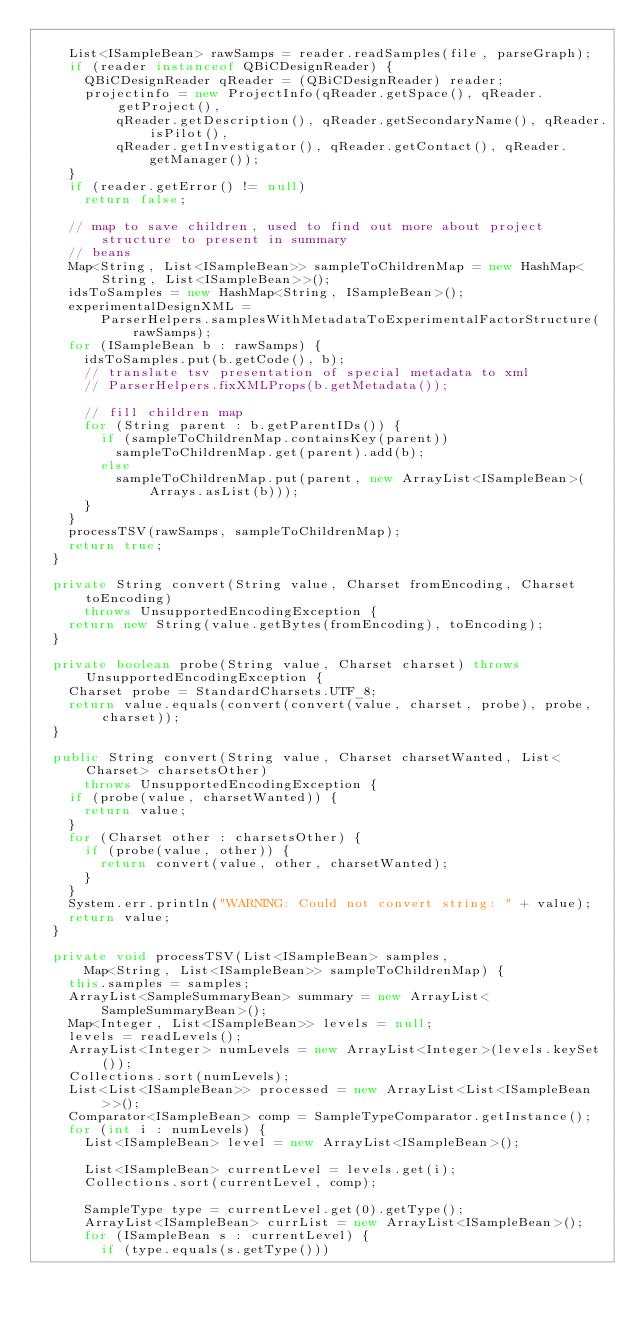Convert code to text. <code><loc_0><loc_0><loc_500><loc_500><_Java_>
    List<ISampleBean> rawSamps = reader.readSamples(file, parseGraph);
    if (reader instanceof QBiCDesignReader) {
      QBiCDesignReader qReader = (QBiCDesignReader) reader;
      projectinfo = new ProjectInfo(qReader.getSpace(), qReader.getProject(),
          qReader.getDescription(), qReader.getSecondaryName(), qReader.isPilot(),
          qReader.getInvestigator(), qReader.getContact(), qReader.getManager());
    }
    if (reader.getError() != null)
      return false;

    // map to save children, used to find out more about project structure to present in summary
    // beans
    Map<String, List<ISampleBean>> sampleToChildrenMap = new HashMap<String, List<ISampleBean>>();
    idsToSamples = new HashMap<String, ISampleBean>();
    experimentalDesignXML =
        ParserHelpers.samplesWithMetadataToExperimentalFactorStructure(rawSamps);
    for (ISampleBean b : rawSamps) {
      idsToSamples.put(b.getCode(), b);
      // translate tsv presentation of special metadata to xml
      // ParserHelpers.fixXMLProps(b.getMetadata());

      // fill children map
      for (String parent : b.getParentIDs()) {
        if (sampleToChildrenMap.containsKey(parent))
          sampleToChildrenMap.get(parent).add(b);
        else
          sampleToChildrenMap.put(parent, new ArrayList<ISampleBean>(Arrays.asList(b)));
      }
    }
    processTSV(rawSamps, sampleToChildrenMap);
    return true;
  }

  private String convert(String value, Charset fromEncoding, Charset toEncoding)
      throws UnsupportedEncodingException {
    return new String(value.getBytes(fromEncoding), toEncoding);
  }

  private boolean probe(String value, Charset charset) throws UnsupportedEncodingException {
    Charset probe = StandardCharsets.UTF_8;
    return value.equals(convert(convert(value, charset, probe), probe, charset));
  }

  public String convert(String value, Charset charsetWanted, List<Charset> charsetsOther)
      throws UnsupportedEncodingException {
    if (probe(value, charsetWanted)) {
      return value;
    }
    for (Charset other : charsetsOther) {
      if (probe(value, other)) {
        return convert(value, other, charsetWanted);
      }
    }
    System.err.println("WARNING: Could not convert string: " + value);
    return value;
  }

  private void processTSV(List<ISampleBean> samples,
      Map<String, List<ISampleBean>> sampleToChildrenMap) {
    this.samples = samples;
    ArrayList<SampleSummaryBean> summary = new ArrayList<SampleSummaryBean>();
    Map<Integer, List<ISampleBean>> levels = null;
    levels = readLevels();
    ArrayList<Integer> numLevels = new ArrayList<Integer>(levels.keySet());
    Collections.sort(numLevels);
    List<List<ISampleBean>> processed = new ArrayList<List<ISampleBean>>();
    Comparator<ISampleBean> comp = SampleTypeComparator.getInstance();
    for (int i : numLevels) {
      List<ISampleBean> level = new ArrayList<ISampleBean>();

      List<ISampleBean> currentLevel = levels.get(i);
      Collections.sort(currentLevel, comp);

      SampleType type = currentLevel.get(0).getType();
      ArrayList<ISampleBean> currList = new ArrayList<ISampleBean>();
      for (ISampleBean s : currentLevel) {
        if (type.equals(s.getType()))</code> 